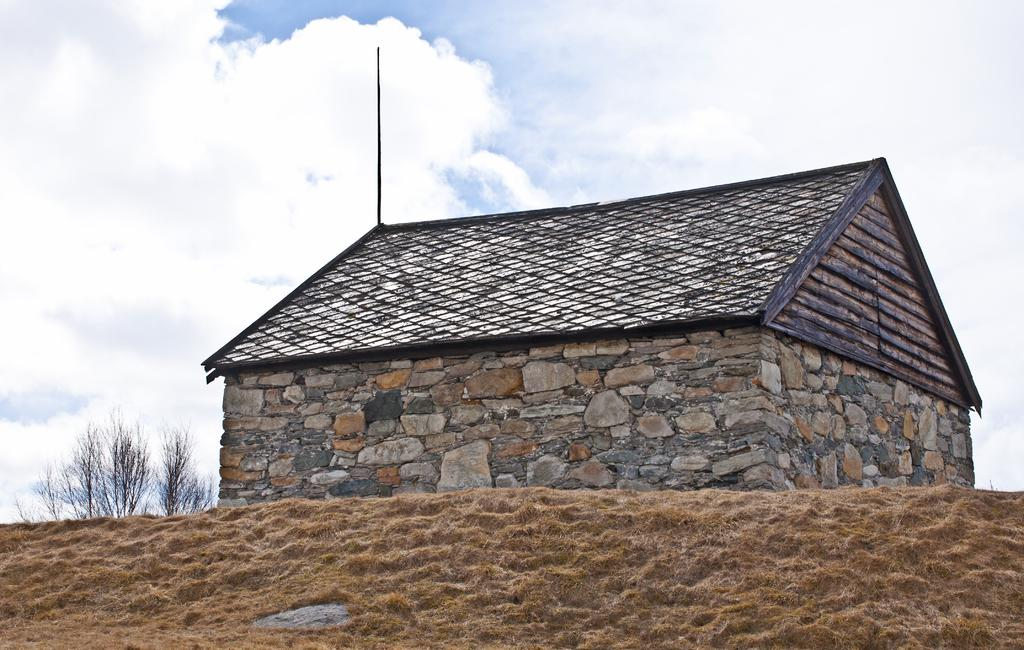What type of house is in the middle of the image? There is a stone house in the middle of the image. What is at the bottom of the image? There is sand at the bottom of the image. What is visible at the top of the image? The sky is visible at the top of the image. What type of vegetation is on the left side of the image? There are small plants on the left side of the image. How does the stone house say good-bye to the foot in the image? There is no foot present in the image, and the stone house cannot say good-bye as it is an inanimate object. 